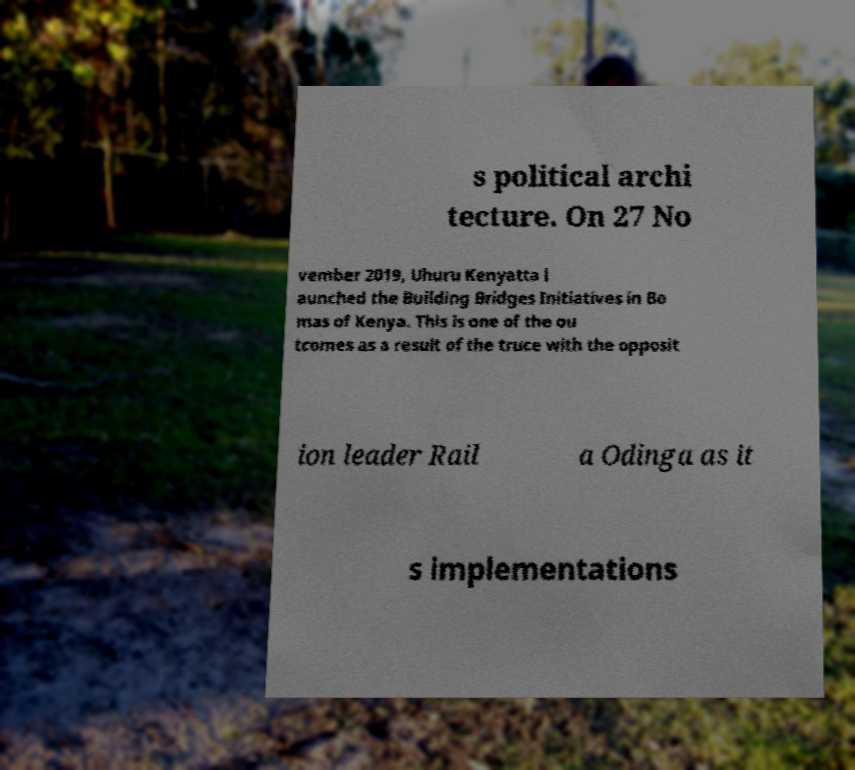For documentation purposes, I need the text within this image transcribed. Could you provide that? s political archi tecture. On 27 No vember 2019, Uhuru Kenyatta l aunched the Building Bridges Initiatives in Bo mas of Kenya. This is one of the ou tcomes as a result of the truce with the opposit ion leader Rail a Odinga as it s implementations 